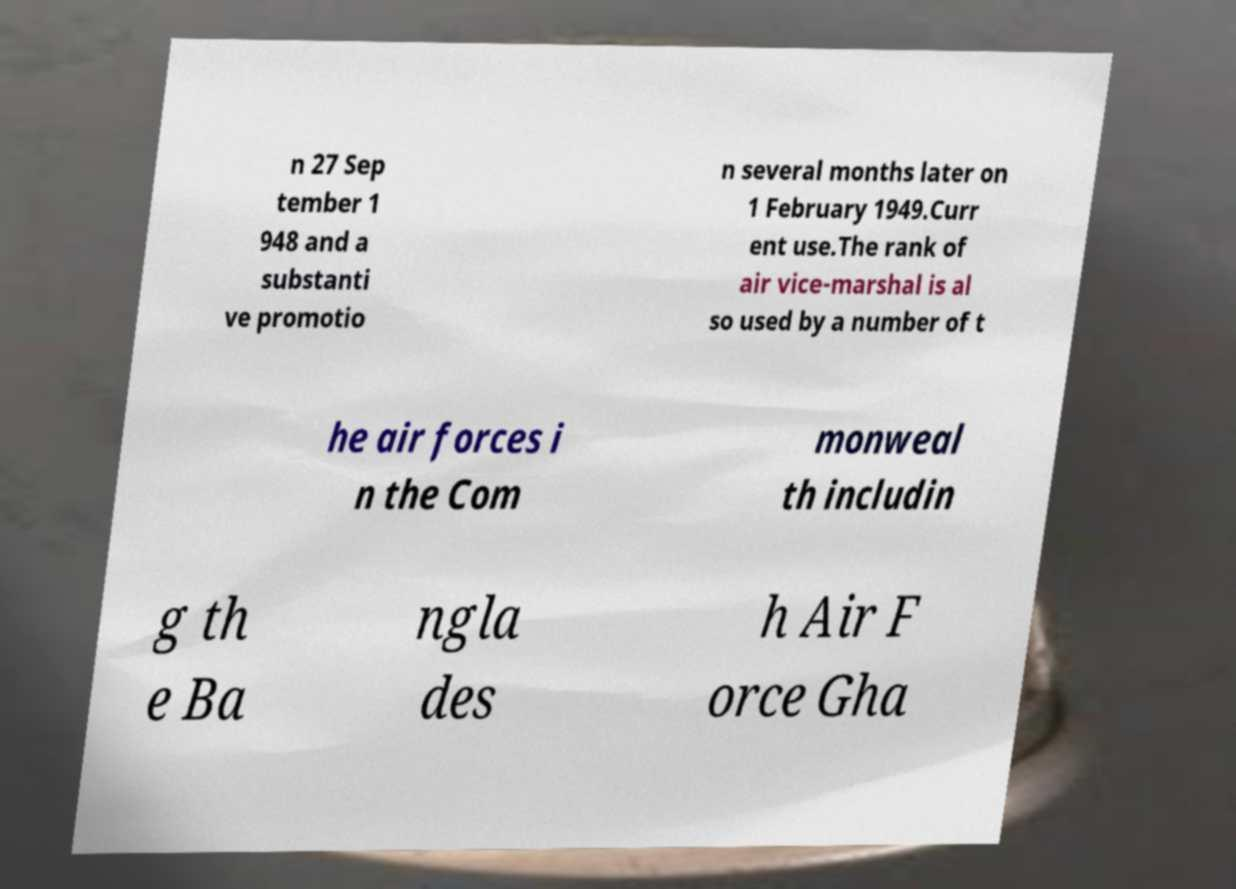Could you extract and type out the text from this image? n 27 Sep tember 1 948 and a substanti ve promotio n several months later on 1 February 1949.Curr ent use.The rank of air vice-marshal is al so used by a number of t he air forces i n the Com monweal th includin g th e Ba ngla des h Air F orce Gha 